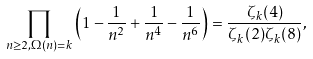Convert formula to latex. <formula><loc_0><loc_0><loc_500><loc_500>\prod _ { n \geq 2 , \Omega ( n ) = k } \left ( 1 - \frac { 1 } { n ^ { 2 } } + \frac { 1 } { n ^ { 4 } } - \frac { 1 } { n ^ { 6 } } \right ) = \frac { \zeta _ { k } ( 4 ) } { \zeta _ { k } ( 2 ) \zeta _ { k } ( 8 ) } ,</formula> 